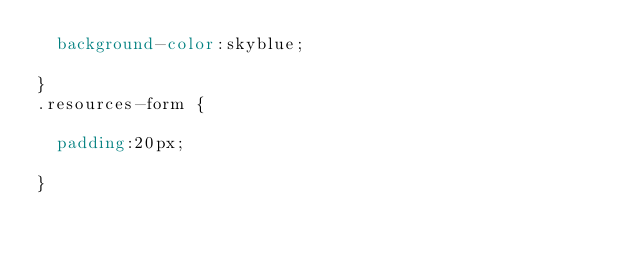Convert code to text. <code><loc_0><loc_0><loc_500><loc_500><_CSS_>  background-color:skyblue;
  
}
.resources-form {

  padding:20px;

}</code> 